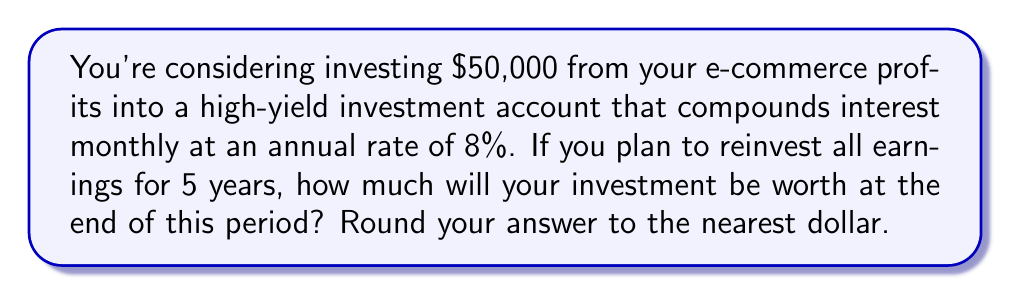Could you help me with this problem? To solve this problem, we'll use the compound interest formula:

$$A = P(1 + \frac{r}{n})^{nt}$$

Where:
$A$ = final amount
$P$ = principal (initial investment)
$r$ = annual interest rate (as a decimal)
$n$ = number of times interest is compounded per year
$t$ = number of years

Given:
$P = \$50,000$
$r = 8\% = 0.08$
$n = 12$ (compounded monthly)
$t = 5$ years

Let's substitute these values into the formula:

$$A = 50000(1 + \frac{0.08}{12})^{12 \times 5}$$

$$A = 50000(1 + 0.006667)^{60}$$

$$A = 50000(1.006667)^{60}$$

Using a calculator or computer to evaluate this expression:

$$A = 50000 \times 1.4859047$$

$$A = 74295.24$$

Rounding to the nearest dollar:

$$A = \$74,295$$
Answer: $74,295 